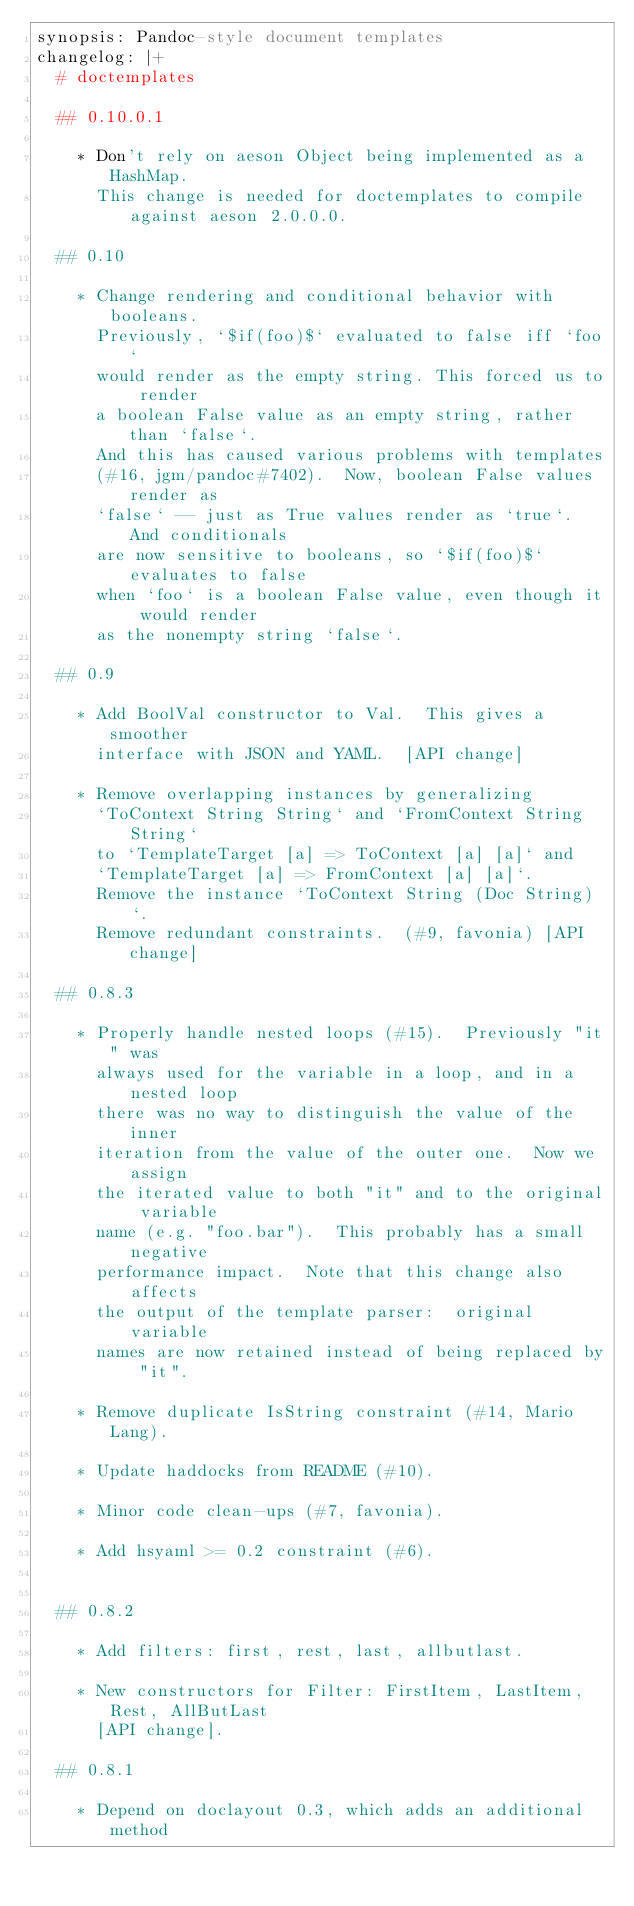Convert code to text. <code><loc_0><loc_0><loc_500><loc_500><_YAML_>synopsis: Pandoc-style document templates
changelog: |+
  # doctemplates

  ## 0.10.0.1

    * Don't rely on aeson Object being implemented as a HashMap.
      This change is needed for doctemplates to compile against aeson 2.0.0.0.

  ## 0.10

    * Change rendering and conditional behavior with booleans.
      Previously, `$if(foo)$` evaluated to false iff `foo`
      would render as the empty string. This forced us to render
      a boolean False value as an empty string, rather than `false`.
      And this has caused various problems with templates
      (#16, jgm/pandoc#7402).  Now, boolean False values render as
      `false` -- just as True values render as `true`.  And conditionals
      are now sensitive to booleans, so `$if(foo)$` evaluates to false
      when `foo` is a boolean False value, even though it would render
      as the nonempty string `false`.

  ## 0.9

    * Add BoolVal constructor to Val.  This gives a smoother
      interface with JSON and YAML.  [API change]

    * Remove overlapping instances by generalizing
      `ToContext String String` and `FromContext String String`
      to `TemplateTarget [a] => ToContext [a] [a]` and
      `TemplateTarget [a] => FromContext [a] [a]`.
      Remove the instance `ToContext String (Doc String)`.
      Remove redundant constraints.  (#9, favonia) [API change]

  ## 0.8.3

    * Properly handle nested loops (#15).  Previously "it" was
      always used for the variable in a loop, and in a nested loop
      there was no way to distinguish the value of the inner
      iteration from the value of the outer one.  Now we assign
      the iterated value to both "it" and to the original variable
      name (e.g. "foo.bar").  This probably has a small negative
      performance impact.  Note that this change also affects
      the output of the template parser:  original variable
      names are now retained instead of being replaced by "it".

    * Remove duplicate IsString constraint (#14, Mario Lang).

    * Update haddocks from README (#10).

    * Minor code clean-ups (#7, favonia).

    * Add hsyaml >= 0.2 constraint (#6).


  ## 0.8.2

    * Add filters: first, rest, last, allbutlast.

    * New constructors for Filter: FirstItem, LastItem, Rest, AllButLast
      [API change].

  ## 0.8.1

    * Depend on doclayout 0.3, which adds an additional method</code> 